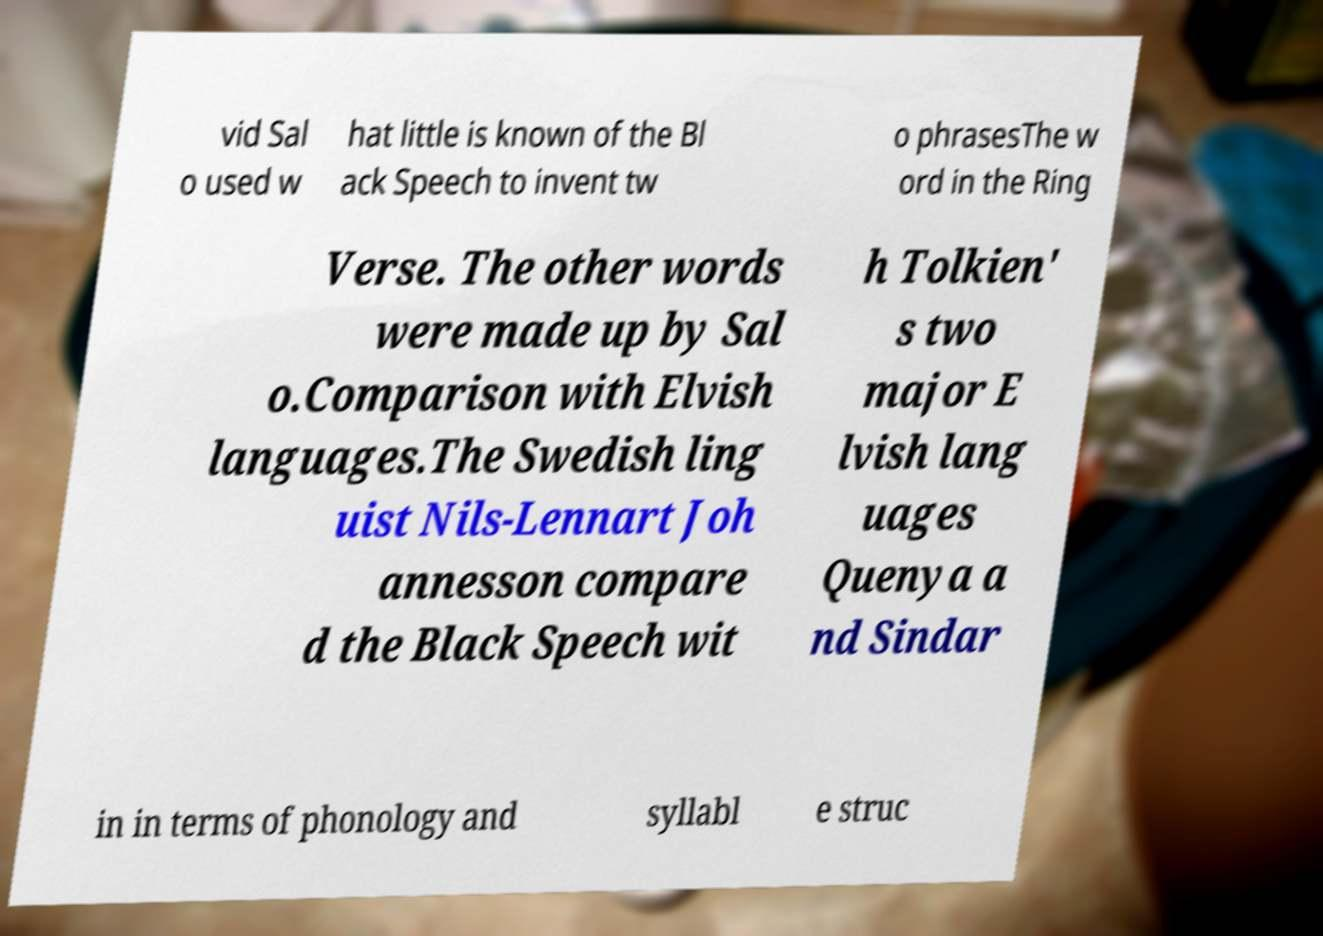Can you accurately transcribe the text from the provided image for me? vid Sal o used w hat little is known of the Bl ack Speech to invent tw o phrasesThe w ord in the Ring Verse. The other words were made up by Sal o.Comparison with Elvish languages.The Swedish ling uist Nils-Lennart Joh annesson compare d the Black Speech wit h Tolkien' s two major E lvish lang uages Quenya a nd Sindar in in terms of phonology and syllabl e struc 